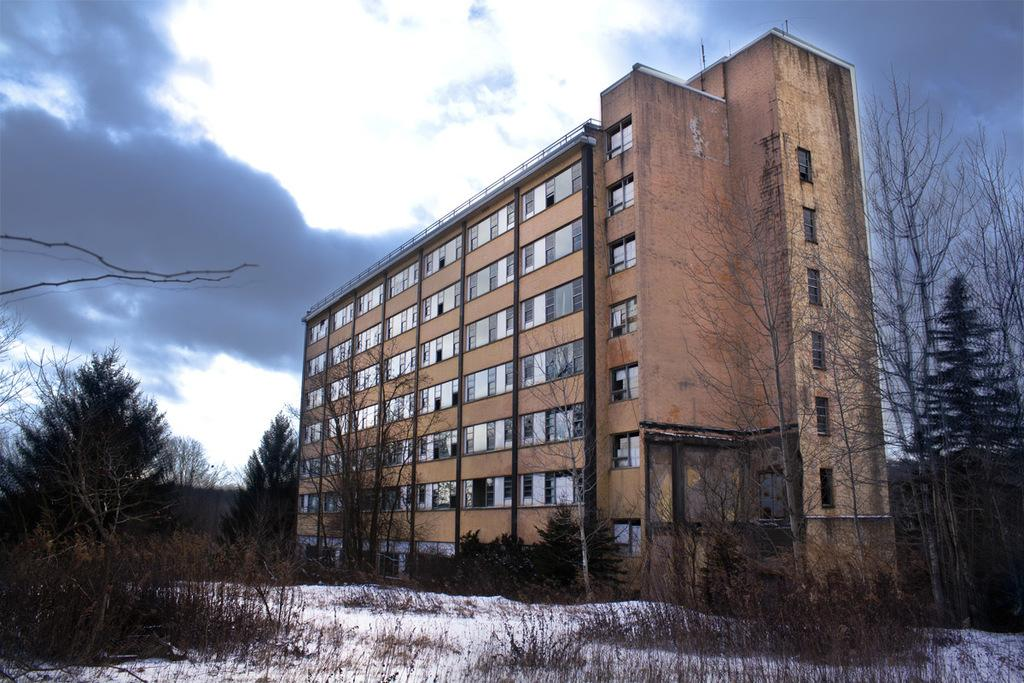What type of vegetation is at the bottom of the image? There are trees at the bottom of the image. What structure is located in the middle of the image? There is a building in the middle of the image. What is the condition of the sky in the image? The sky is cloudy at the top of the image. What type of boot can be seen in the image? There is no boot present in the image. What country is depicted in the image? The image does not depict a specific country; it only shows trees, a building, and a cloudy sky. 